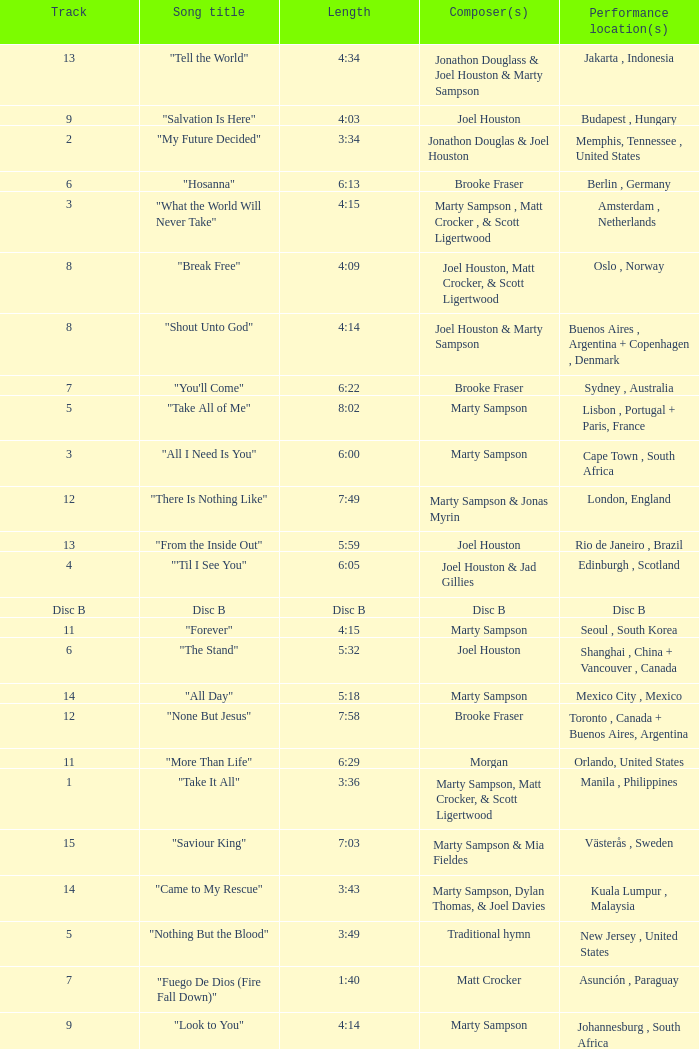What is the lengtho f track 16? 5:55. 